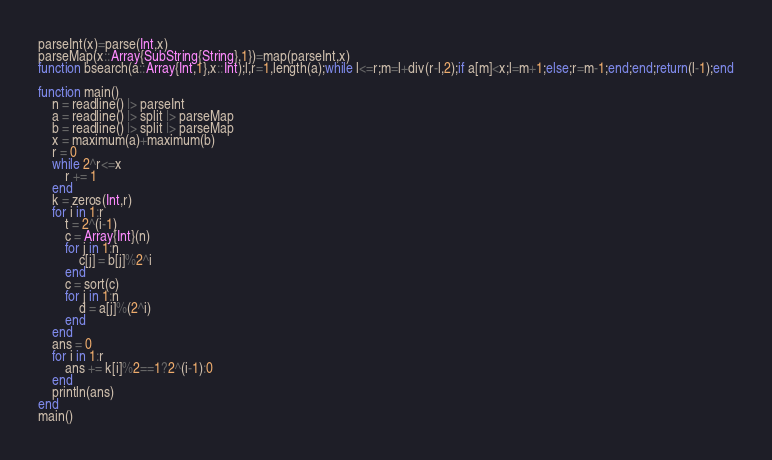Convert code to text. <code><loc_0><loc_0><loc_500><loc_500><_Julia_>parseInt(x)=parse(Int,x)
parseMap(x::Array{SubString{String},1})=map(parseInt,x)
function bsearch(a::Array{Int,1},x::Int);l,r=1,length(a);while l<=r;m=l+div(r-l,2);if a[m]<x;l=m+1;else;r=m-1;end;end;return(l-1);end

function main()
	n = readline() |> parseInt
	a = readline() |> split |> parseMap
	b = readline() |> split |> parseMap
	x = maximum(a)+maximum(b)
	r = 0
	while 2^r<=x
		r += 1
	end
	k = zeros(Int,r)
	for i in 1:r
		t = 2^(i-1)
		c = Array{Int}(n)
		for j in 1:n
			c[j] = b[j]%2^i
		end
		c = sort(c)
		for j in 1:n
			d = a[j]%(2^i)
		end
	end
	ans = 0
	for i in 1:r
		ans += k[i]%2==1?2^(i-1):0
	end
	println(ans)
end
main()
</code> 